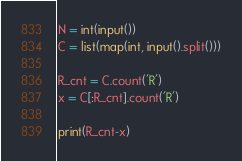<code> <loc_0><loc_0><loc_500><loc_500><_Python_>N = int(input())
C = list(map(int, input().split()))

R_cnt = C.count('R')
x = C[:R_cnt].count('R')

print(R_cnt-x)</code> 